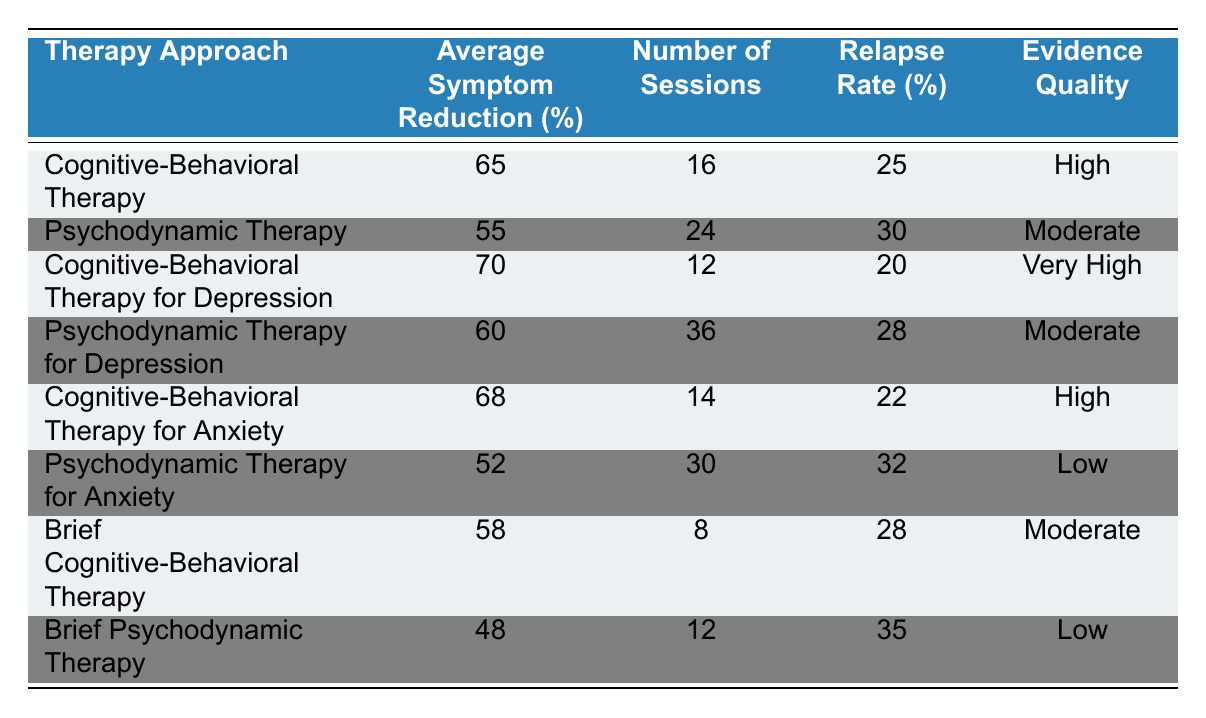What is the average symptom reduction percentage for Cognitive-Behavioral Therapy? The table shows that the average symptom reduction for Cognitive-Behavioral Therapy is 65%.
Answer: 65% What is the relapse rate for Psychodynamic Therapy? According to the table, the relapse rate for Psychodynamic Therapy is 30%.
Answer: 30% Which therapy approach has a higher average symptom reduction, Cognitive-Behavioral Therapy or Psychodynamic Therapy? Cognitive-Behavioral Therapy has an average symptom reduction of 65%, while Psychodynamic Therapy has 55%. Therefore, Cognitive-Behavioral Therapy has a higher average symptom reduction.
Answer: Yes, Cognitive-Behavioral Therapy What is the average number of sessions for Brief Psychodynamic Therapy? The table indicates that Brief Psychodynamic Therapy requires an average of 12 sessions.
Answer: 12 What is the difference in the average symptom reduction between Cognitive-Behavioral Therapy for Anxiety and Psychodynamic Therapy for Anxiety? Cognitive-Behavioral Therapy for Anxiety has an average symptom reduction of 68%, while Psychodynamic Therapy for Anxiety has 52%. The difference is 68% - 52% = 16%.
Answer: 16% Does the evidence quality for Brief Cognitive-Behavioral Therapy differ from that of Psychodynamic Therapy for Anxiety? The evidence quality for Brief Cognitive-Behavioral Therapy is Moderate, while for Psychodynamic Therapy for Anxiety it is Low. Therefore, they do differ.
Answer: Yes What is the total average symptom reduction across all Cognitive-Behavioral Therapy approaches? The averages are 65%, 70%, 68%, and 58%. The total is 65 + 70 + 68 + 58 = 261, and dividing by 4 gives an average of 261 / 4 = 65.25%.
Answer: 65.25% How many more sessions are required on average for Psychodynamic Therapy for Depression compared to Cognitive-Behavioral Therapy for Depression? Psychodynamic Therapy for Depression requires 36 sessions, while Cognitive-Behavioral Therapy for Depression requires 12 sessions. The difference is 36 - 12 = 24 sessions.
Answer: 24 What is the average relapse rate for all types of Psychodynamic Therapy? The three Psychodynamic Therapy types have relapse rates of 30%, 28%, and 32%. The total sum is 30 + 28 + 32 = 90, and the average is 90 / 3 = 30%.
Answer: 30% 